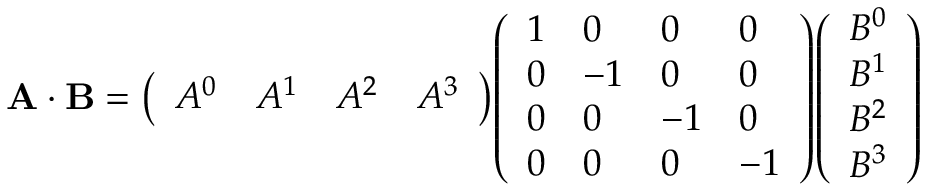Convert formula to latex. <formula><loc_0><loc_0><loc_500><loc_500>A \cdot B = { \left ( \begin{array} { l l l l } { A ^ { 0 } } & { A ^ { 1 } } & { A ^ { 2 } } & { A ^ { 3 } } \end{array} \right ) } { \left ( \begin{array} { l l l l } { 1 } & { 0 } & { 0 } & { 0 } \\ { 0 } & { - 1 } & { 0 } & { 0 } \\ { 0 } & { 0 } & { - 1 } & { 0 } \\ { 0 } & { 0 } & { 0 } & { - 1 } \end{array} \right ) } { \left ( \begin{array} { l } { B ^ { 0 } } \\ { B ^ { 1 } } \\ { B ^ { 2 } } \\ { B ^ { 3 } } \end{array} \right ) }</formula> 